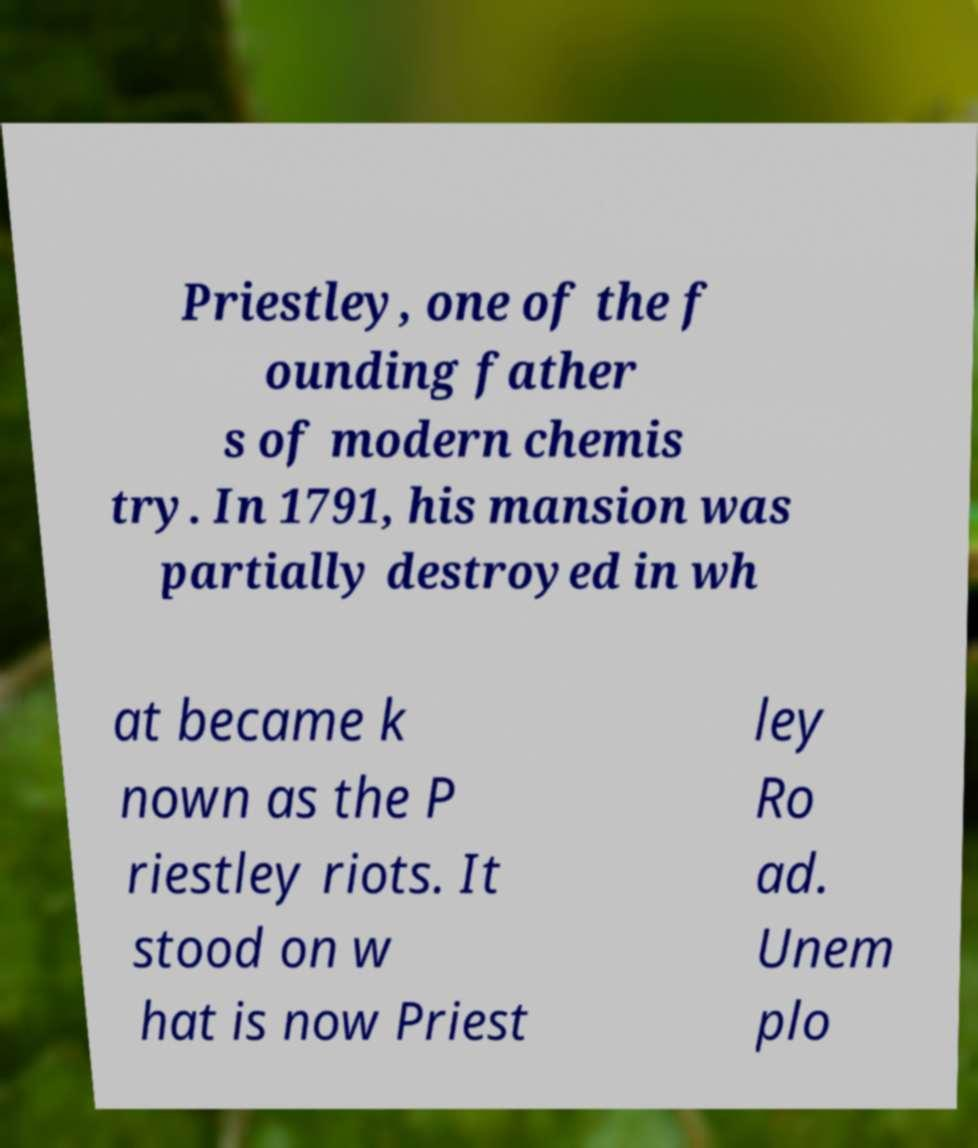Can you accurately transcribe the text from the provided image for me? Priestley, one of the f ounding father s of modern chemis try. In 1791, his mansion was partially destroyed in wh at became k nown as the P riestley riots. It stood on w hat is now Priest ley Ro ad. Unem plo 